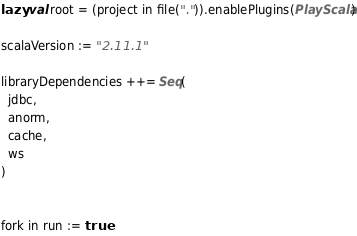<code> <loc_0><loc_0><loc_500><loc_500><_Scala_>lazy val root = (project in file(".")).enablePlugins(PlayScala)

scalaVersion := "2.11.1"

libraryDependencies ++= Seq(
  jdbc,
  anorm,
  cache,
  ws
)


fork in run := true</code> 